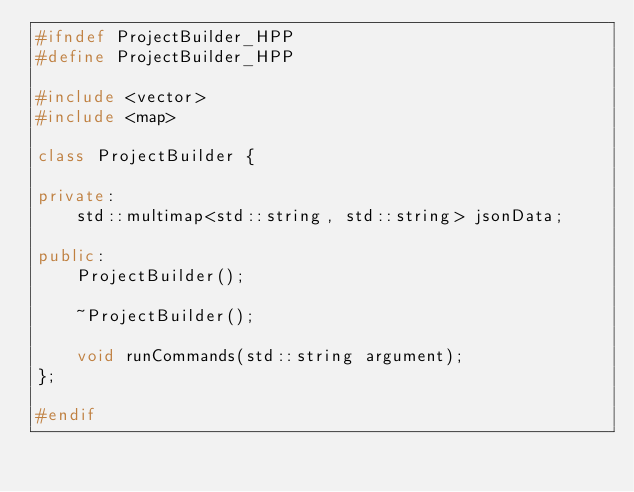<code> <loc_0><loc_0><loc_500><loc_500><_C++_>#ifndef ProjectBuilder_HPP
#define ProjectBuilder_HPP

#include <vector>
#include <map>

class ProjectBuilder {

private:
    std::multimap<std::string, std::string> jsonData;

public:
    ProjectBuilder();

    ~ProjectBuilder();

    void runCommands(std::string argument);
};

#endif</code> 